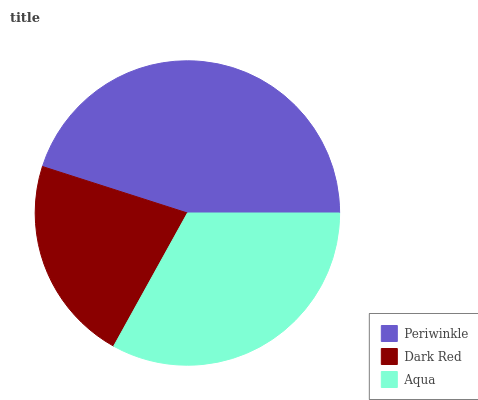Is Dark Red the minimum?
Answer yes or no. Yes. Is Periwinkle the maximum?
Answer yes or no. Yes. Is Aqua the minimum?
Answer yes or no. No. Is Aqua the maximum?
Answer yes or no. No. Is Aqua greater than Dark Red?
Answer yes or no. Yes. Is Dark Red less than Aqua?
Answer yes or no. Yes. Is Dark Red greater than Aqua?
Answer yes or no. No. Is Aqua less than Dark Red?
Answer yes or no. No. Is Aqua the high median?
Answer yes or no. Yes. Is Aqua the low median?
Answer yes or no. Yes. Is Periwinkle the high median?
Answer yes or no. No. Is Periwinkle the low median?
Answer yes or no. No. 